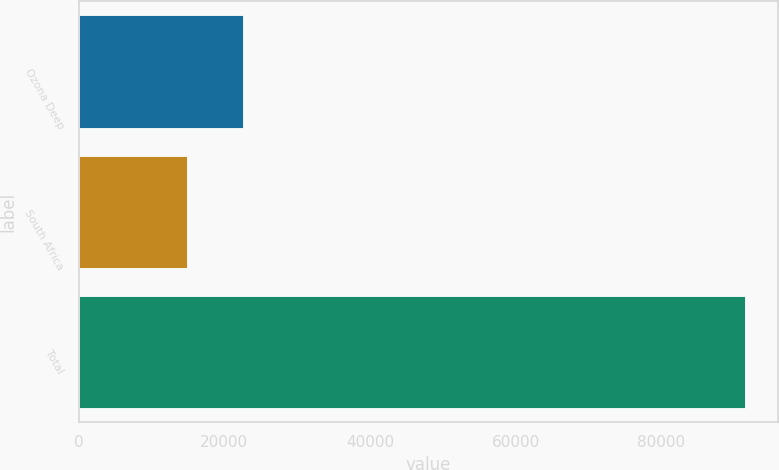Convert chart. <chart><loc_0><loc_0><loc_500><loc_500><bar_chart><fcel>Ozona Deep<fcel>South Africa<fcel>Total<nl><fcel>22548.1<fcel>14895<fcel>91426<nl></chart> 